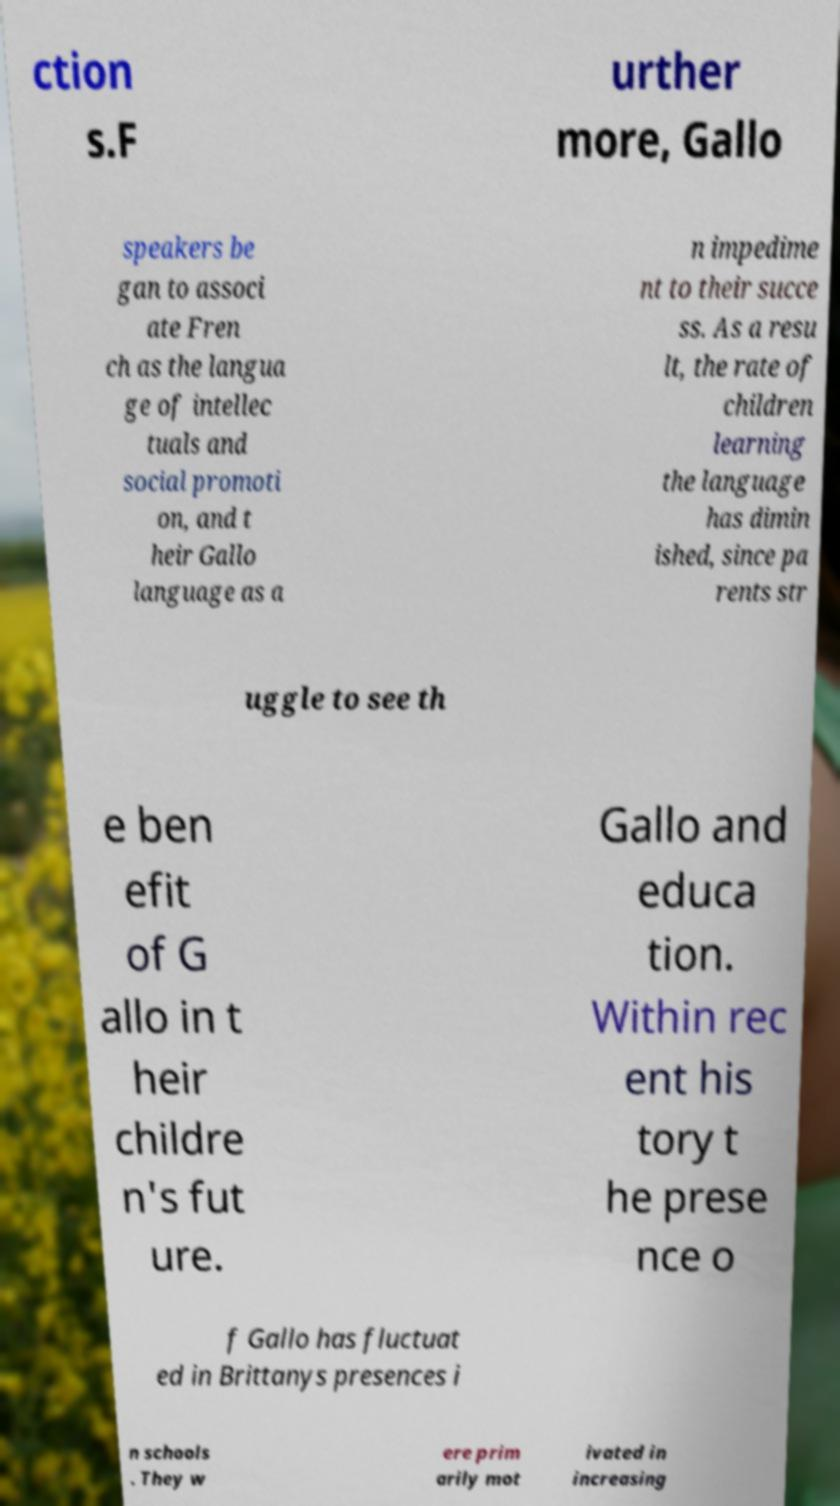I need the written content from this picture converted into text. Can you do that? ction s.F urther more, Gallo speakers be gan to associ ate Fren ch as the langua ge of intellec tuals and social promoti on, and t heir Gallo language as a n impedime nt to their succe ss. As a resu lt, the rate of children learning the language has dimin ished, since pa rents str uggle to see th e ben efit of G allo in t heir childre n's fut ure. Gallo and educa tion. Within rec ent his tory t he prese nce o f Gallo has fluctuat ed in Brittanys presences i n schools . They w ere prim arily mot ivated in increasing 